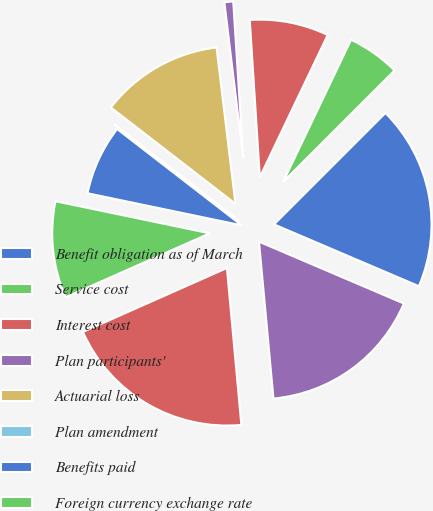Convert chart. <chart><loc_0><loc_0><loc_500><loc_500><pie_chart><fcel>Benefit obligation as of March<fcel>Service cost<fcel>Interest cost<fcel>Plan participants'<fcel>Actuarial loss<fcel>Plan amendment<fcel>Benefits paid<fcel>Foreign currency exchange rate<fcel>Benefit obligation as of the<fcel>Fair value of plan assets as<nl><fcel>18.92%<fcel>5.41%<fcel>8.11%<fcel>0.9%<fcel>12.61%<fcel>0.0%<fcel>7.21%<fcel>9.91%<fcel>19.82%<fcel>17.12%<nl></chart> 